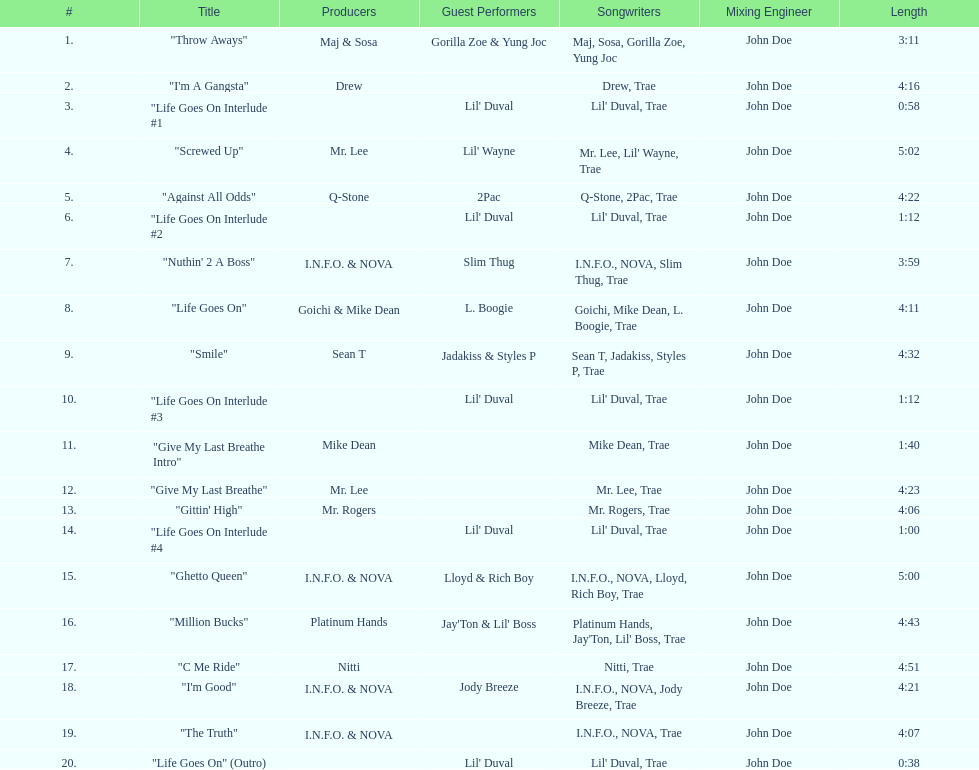How many tracks on trae's album "life goes on"? 20. 